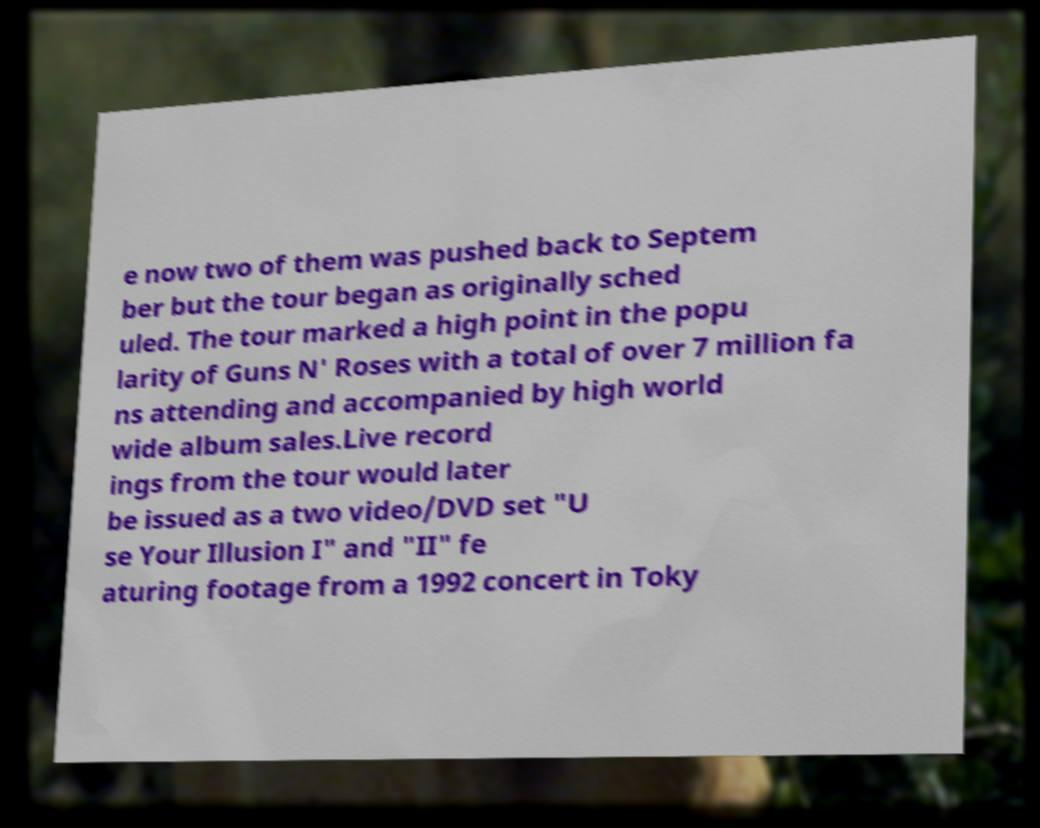For documentation purposes, I need the text within this image transcribed. Could you provide that? e now two of them was pushed back to Septem ber but the tour began as originally sched uled. The tour marked a high point in the popu larity of Guns N' Roses with a total of over 7 million fa ns attending and accompanied by high world wide album sales.Live record ings from the tour would later be issued as a two video/DVD set "U se Your Illusion I" and "II" fe aturing footage from a 1992 concert in Toky 